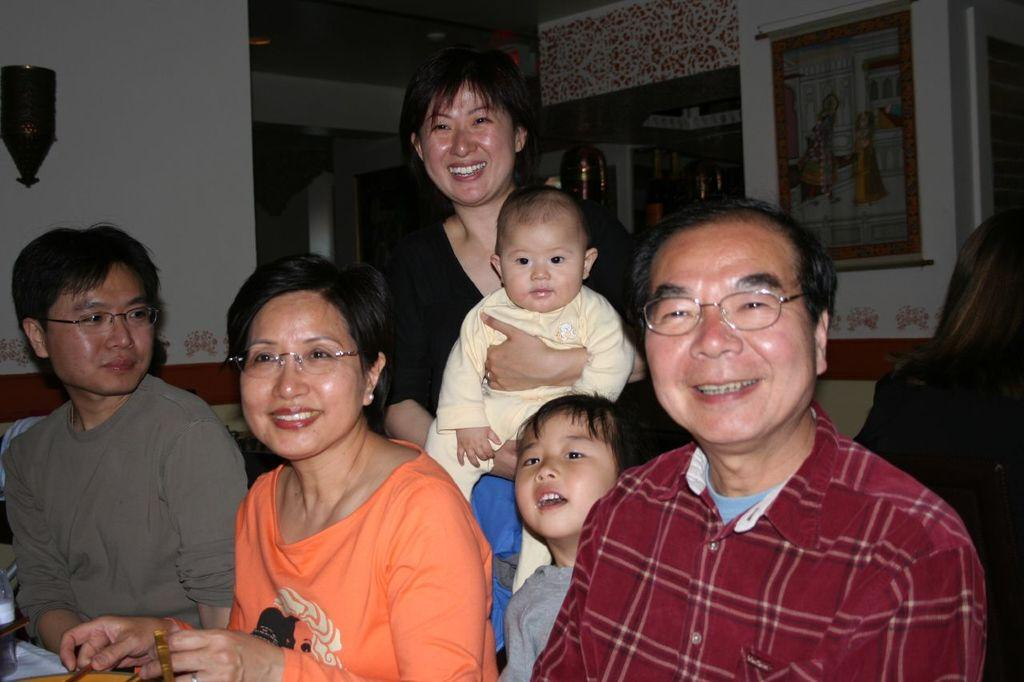How many people are in the group that is visible in the image? There is a group of people in the image. What are the people in the group doing? The group of people are posing for a picture. Can you describe the person carrying a baby in the group? One person in the group is carrying a baby. What type of artwork can be seen in the image? There is a painting visible in the image. What kind of wall decor is present in the image? There is a wall decor in the image. What other objects can be seen in the image? There are a few other objects in the image. What type of volleyball game is being played in the image? There is no volleyball game present in the image. Can you describe the dog that is playing with the baby in the image? There is no dog present in the image. 